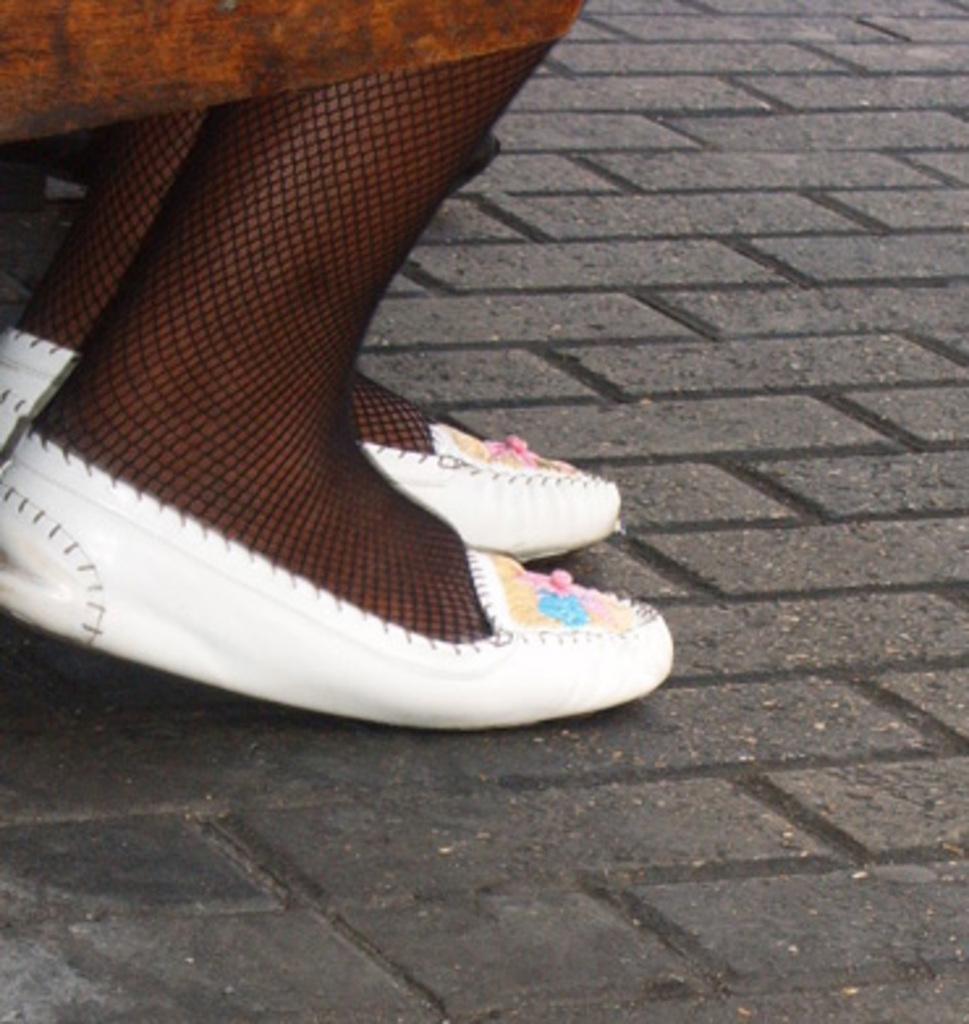In one or two sentences, can you explain what this image depicts? In this image I see a person's legs and I see white color shoes on the legs and I see the path. 